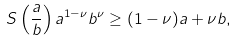<formula> <loc_0><loc_0><loc_500><loc_500>S \left ( \frac { a } { b } \right ) a ^ { 1 - \nu } b ^ { \nu } \geq ( 1 - \nu ) a + \nu b ,</formula> 